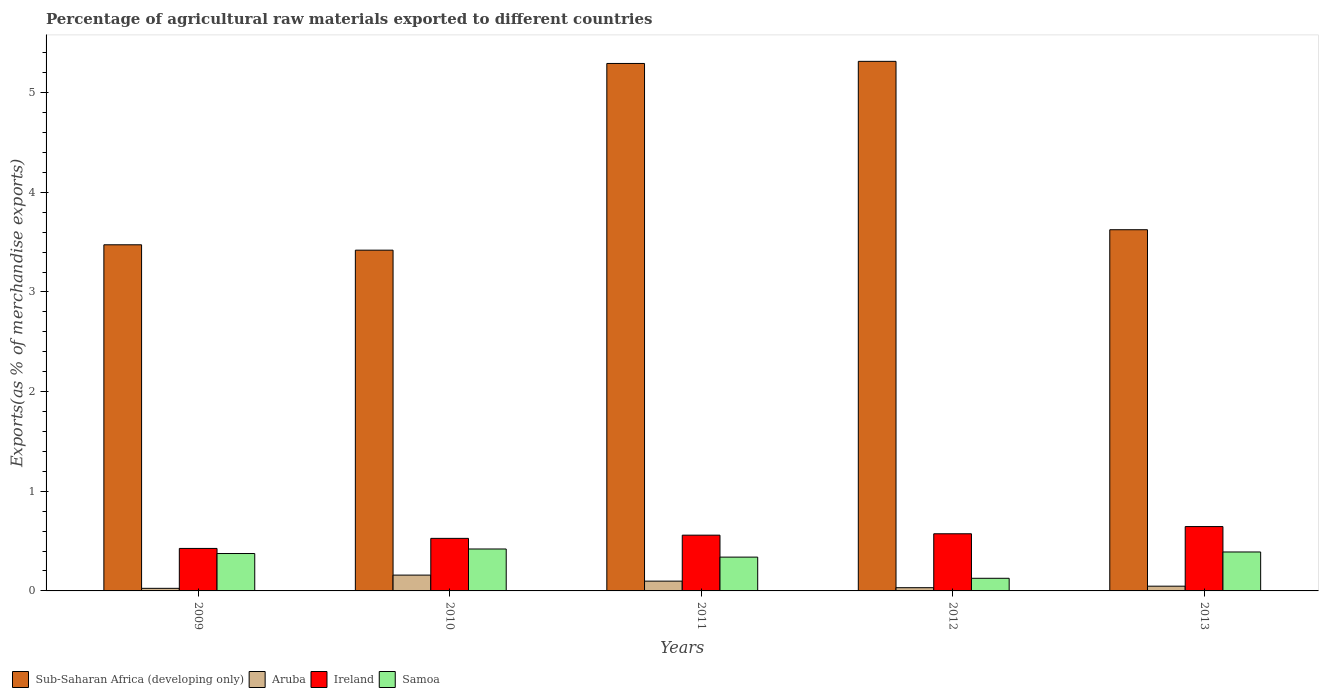How many groups of bars are there?
Offer a terse response. 5. How many bars are there on the 4th tick from the right?
Offer a very short reply. 4. What is the label of the 3rd group of bars from the left?
Ensure brevity in your answer.  2011. In how many cases, is the number of bars for a given year not equal to the number of legend labels?
Provide a short and direct response. 0. What is the percentage of exports to different countries in Sub-Saharan Africa (developing only) in 2012?
Provide a short and direct response. 5.31. Across all years, what is the maximum percentage of exports to different countries in Aruba?
Make the answer very short. 0.16. Across all years, what is the minimum percentage of exports to different countries in Sub-Saharan Africa (developing only)?
Offer a terse response. 3.42. What is the total percentage of exports to different countries in Aruba in the graph?
Your answer should be very brief. 0.36. What is the difference between the percentage of exports to different countries in Samoa in 2011 and that in 2013?
Your response must be concise. -0.05. What is the difference between the percentage of exports to different countries in Samoa in 2009 and the percentage of exports to different countries in Sub-Saharan Africa (developing only) in 2013?
Ensure brevity in your answer.  -3.25. What is the average percentage of exports to different countries in Sub-Saharan Africa (developing only) per year?
Give a very brief answer. 4.22. In the year 2011, what is the difference between the percentage of exports to different countries in Samoa and percentage of exports to different countries in Aruba?
Provide a succinct answer. 0.24. What is the ratio of the percentage of exports to different countries in Sub-Saharan Africa (developing only) in 2009 to that in 2012?
Provide a succinct answer. 0.65. Is the difference between the percentage of exports to different countries in Samoa in 2010 and 2011 greater than the difference between the percentage of exports to different countries in Aruba in 2010 and 2011?
Your answer should be very brief. Yes. What is the difference between the highest and the second highest percentage of exports to different countries in Samoa?
Make the answer very short. 0.03. What is the difference between the highest and the lowest percentage of exports to different countries in Ireland?
Give a very brief answer. 0.22. Is it the case that in every year, the sum of the percentage of exports to different countries in Aruba and percentage of exports to different countries in Ireland is greater than the sum of percentage of exports to different countries in Sub-Saharan Africa (developing only) and percentage of exports to different countries in Samoa?
Offer a very short reply. Yes. What does the 3rd bar from the left in 2009 represents?
Your answer should be compact. Ireland. What does the 2nd bar from the right in 2009 represents?
Make the answer very short. Ireland. Are all the bars in the graph horizontal?
Your response must be concise. No. Where does the legend appear in the graph?
Your answer should be compact. Bottom left. How many legend labels are there?
Offer a very short reply. 4. How are the legend labels stacked?
Your answer should be compact. Horizontal. What is the title of the graph?
Your response must be concise. Percentage of agricultural raw materials exported to different countries. What is the label or title of the X-axis?
Your answer should be compact. Years. What is the label or title of the Y-axis?
Provide a succinct answer. Exports(as % of merchandise exports). What is the Exports(as % of merchandise exports) of Sub-Saharan Africa (developing only) in 2009?
Keep it short and to the point. 3.47. What is the Exports(as % of merchandise exports) of Aruba in 2009?
Offer a very short reply. 0.03. What is the Exports(as % of merchandise exports) in Ireland in 2009?
Keep it short and to the point. 0.43. What is the Exports(as % of merchandise exports) of Samoa in 2009?
Provide a short and direct response. 0.38. What is the Exports(as % of merchandise exports) of Sub-Saharan Africa (developing only) in 2010?
Give a very brief answer. 3.42. What is the Exports(as % of merchandise exports) of Aruba in 2010?
Ensure brevity in your answer.  0.16. What is the Exports(as % of merchandise exports) in Ireland in 2010?
Offer a terse response. 0.53. What is the Exports(as % of merchandise exports) of Samoa in 2010?
Offer a terse response. 0.42. What is the Exports(as % of merchandise exports) in Sub-Saharan Africa (developing only) in 2011?
Give a very brief answer. 5.29. What is the Exports(as % of merchandise exports) of Aruba in 2011?
Provide a succinct answer. 0.1. What is the Exports(as % of merchandise exports) in Ireland in 2011?
Offer a very short reply. 0.56. What is the Exports(as % of merchandise exports) of Samoa in 2011?
Give a very brief answer. 0.34. What is the Exports(as % of merchandise exports) in Sub-Saharan Africa (developing only) in 2012?
Your answer should be compact. 5.31. What is the Exports(as % of merchandise exports) of Aruba in 2012?
Make the answer very short. 0.03. What is the Exports(as % of merchandise exports) of Ireland in 2012?
Your response must be concise. 0.57. What is the Exports(as % of merchandise exports) of Samoa in 2012?
Your answer should be very brief. 0.13. What is the Exports(as % of merchandise exports) of Sub-Saharan Africa (developing only) in 2013?
Your answer should be very brief. 3.62. What is the Exports(as % of merchandise exports) of Aruba in 2013?
Offer a very short reply. 0.05. What is the Exports(as % of merchandise exports) in Ireland in 2013?
Offer a very short reply. 0.65. What is the Exports(as % of merchandise exports) of Samoa in 2013?
Keep it short and to the point. 0.39. Across all years, what is the maximum Exports(as % of merchandise exports) in Sub-Saharan Africa (developing only)?
Make the answer very short. 5.31. Across all years, what is the maximum Exports(as % of merchandise exports) in Aruba?
Make the answer very short. 0.16. Across all years, what is the maximum Exports(as % of merchandise exports) of Ireland?
Offer a terse response. 0.65. Across all years, what is the maximum Exports(as % of merchandise exports) of Samoa?
Provide a short and direct response. 0.42. Across all years, what is the minimum Exports(as % of merchandise exports) in Sub-Saharan Africa (developing only)?
Give a very brief answer. 3.42. Across all years, what is the minimum Exports(as % of merchandise exports) of Aruba?
Provide a succinct answer. 0.03. Across all years, what is the minimum Exports(as % of merchandise exports) of Ireland?
Keep it short and to the point. 0.43. Across all years, what is the minimum Exports(as % of merchandise exports) of Samoa?
Offer a terse response. 0.13. What is the total Exports(as % of merchandise exports) of Sub-Saharan Africa (developing only) in the graph?
Give a very brief answer. 21.12. What is the total Exports(as % of merchandise exports) in Aruba in the graph?
Your response must be concise. 0.36. What is the total Exports(as % of merchandise exports) in Ireland in the graph?
Offer a very short reply. 2.73. What is the total Exports(as % of merchandise exports) of Samoa in the graph?
Give a very brief answer. 1.65. What is the difference between the Exports(as % of merchandise exports) in Sub-Saharan Africa (developing only) in 2009 and that in 2010?
Your answer should be compact. 0.05. What is the difference between the Exports(as % of merchandise exports) in Aruba in 2009 and that in 2010?
Your answer should be very brief. -0.13. What is the difference between the Exports(as % of merchandise exports) in Ireland in 2009 and that in 2010?
Ensure brevity in your answer.  -0.1. What is the difference between the Exports(as % of merchandise exports) in Samoa in 2009 and that in 2010?
Your response must be concise. -0.05. What is the difference between the Exports(as % of merchandise exports) in Sub-Saharan Africa (developing only) in 2009 and that in 2011?
Your response must be concise. -1.82. What is the difference between the Exports(as % of merchandise exports) of Aruba in 2009 and that in 2011?
Your answer should be compact. -0.07. What is the difference between the Exports(as % of merchandise exports) of Ireland in 2009 and that in 2011?
Ensure brevity in your answer.  -0.13. What is the difference between the Exports(as % of merchandise exports) of Samoa in 2009 and that in 2011?
Give a very brief answer. 0.04. What is the difference between the Exports(as % of merchandise exports) of Sub-Saharan Africa (developing only) in 2009 and that in 2012?
Provide a short and direct response. -1.84. What is the difference between the Exports(as % of merchandise exports) of Aruba in 2009 and that in 2012?
Offer a very short reply. -0.01. What is the difference between the Exports(as % of merchandise exports) in Ireland in 2009 and that in 2012?
Your response must be concise. -0.15. What is the difference between the Exports(as % of merchandise exports) in Samoa in 2009 and that in 2012?
Keep it short and to the point. 0.25. What is the difference between the Exports(as % of merchandise exports) in Sub-Saharan Africa (developing only) in 2009 and that in 2013?
Your response must be concise. -0.15. What is the difference between the Exports(as % of merchandise exports) in Aruba in 2009 and that in 2013?
Provide a short and direct response. -0.02. What is the difference between the Exports(as % of merchandise exports) in Ireland in 2009 and that in 2013?
Your answer should be compact. -0.22. What is the difference between the Exports(as % of merchandise exports) of Samoa in 2009 and that in 2013?
Give a very brief answer. -0.02. What is the difference between the Exports(as % of merchandise exports) in Sub-Saharan Africa (developing only) in 2010 and that in 2011?
Offer a terse response. -1.87. What is the difference between the Exports(as % of merchandise exports) in Aruba in 2010 and that in 2011?
Give a very brief answer. 0.06. What is the difference between the Exports(as % of merchandise exports) of Ireland in 2010 and that in 2011?
Ensure brevity in your answer.  -0.03. What is the difference between the Exports(as % of merchandise exports) of Samoa in 2010 and that in 2011?
Give a very brief answer. 0.08. What is the difference between the Exports(as % of merchandise exports) of Sub-Saharan Africa (developing only) in 2010 and that in 2012?
Your response must be concise. -1.89. What is the difference between the Exports(as % of merchandise exports) of Aruba in 2010 and that in 2012?
Offer a terse response. 0.13. What is the difference between the Exports(as % of merchandise exports) in Ireland in 2010 and that in 2012?
Your response must be concise. -0.05. What is the difference between the Exports(as % of merchandise exports) in Samoa in 2010 and that in 2012?
Provide a succinct answer. 0.29. What is the difference between the Exports(as % of merchandise exports) of Sub-Saharan Africa (developing only) in 2010 and that in 2013?
Provide a short and direct response. -0.2. What is the difference between the Exports(as % of merchandise exports) in Aruba in 2010 and that in 2013?
Provide a succinct answer. 0.11. What is the difference between the Exports(as % of merchandise exports) in Ireland in 2010 and that in 2013?
Offer a terse response. -0.12. What is the difference between the Exports(as % of merchandise exports) of Samoa in 2010 and that in 2013?
Make the answer very short. 0.03. What is the difference between the Exports(as % of merchandise exports) in Sub-Saharan Africa (developing only) in 2011 and that in 2012?
Keep it short and to the point. -0.02. What is the difference between the Exports(as % of merchandise exports) of Aruba in 2011 and that in 2012?
Ensure brevity in your answer.  0.07. What is the difference between the Exports(as % of merchandise exports) of Ireland in 2011 and that in 2012?
Offer a terse response. -0.01. What is the difference between the Exports(as % of merchandise exports) in Samoa in 2011 and that in 2012?
Ensure brevity in your answer.  0.21. What is the difference between the Exports(as % of merchandise exports) of Sub-Saharan Africa (developing only) in 2011 and that in 2013?
Offer a terse response. 1.67. What is the difference between the Exports(as % of merchandise exports) in Aruba in 2011 and that in 2013?
Your answer should be very brief. 0.05. What is the difference between the Exports(as % of merchandise exports) of Ireland in 2011 and that in 2013?
Provide a succinct answer. -0.09. What is the difference between the Exports(as % of merchandise exports) in Samoa in 2011 and that in 2013?
Provide a short and direct response. -0.05. What is the difference between the Exports(as % of merchandise exports) in Sub-Saharan Africa (developing only) in 2012 and that in 2013?
Offer a very short reply. 1.69. What is the difference between the Exports(as % of merchandise exports) in Aruba in 2012 and that in 2013?
Your response must be concise. -0.02. What is the difference between the Exports(as % of merchandise exports) of Ireland in 2012 and that in 2013?
Offer a terse response. -0.07. What is the difference between the Exports(as % of merchandise exports) in Samoa in 2012 and that in 2013?
Your response must be concise. -0.26. What is the difference between the Exports(as % of merchandise exports) in Sub-Saharan Africa (developing only) in 2009 and the Exports(as % of merchandise exports) in Aruba in 2010?
Offer a terse response. 3.31. What is the difference between the Exports(as % of merchandise exports) in Sub-Saharan Africa (developing only) in 2009 and the Exports(as % of merchandise exports) in Ireland in 2010?
Provide a succinct answer. 2.95. What is the difference between the Exports(as % of merchandise exports) of Sub-Saharan Africa (developing only) in 2009 and the Exports(as % of merchandise exports) of Samoa in 2010?
Keep it short and to the point. 3.05. What is the difference between the Exports(as % of merchandise exports) of Aruba in 2009 and the Exports(as % of merchandise exports) of Ireland in 2010?
Ensure brevity in your answer.  -0.5. What is the difference between the Exports(as % of merchandise exports) of Aruba in 2009 and the Exports(as % of merchandise exports) of Samoa in 2010?
Provide a short and direct response. -0.39. What is the difference between the Exports(as % of merchandise exports) of Ireland in 2009 and the Exports(as % of merchandise exports) of Samoa in 2010?
Your answer should be compact. 0.01. What is the difference between the Exports(as % of merchandise exports) of Sub-Saharan Africa (developing only) in 2009 and the Exports(as % of merchandise exports) of Aruba in 2011?
Provide a succinct answer. 3.38. What is the difference between the Exports(as % of merchandise exports) of Sub-Saharan Africa (developing only) in 2009 and the Exports(as % of merchandise exports) of Ireland in 2011?
Make the answer very short. 2.91. What is the difference between the Exports(as % of merchandise exports) of Sub-Saharan Africa (developing only) in 2009 and the Exports(as % of merchandise exports) of Samoa in 2011?
Offer a terse response. 3.13. What is the difference between the Exports(as % of merchandise exports) in Aruba in 2009 and the Exports(as % of merchandise exports) in Ireland in 2011?
Ensure brevity in your answer.  -0.53. What is the difference between the Exports(as % of merchandise exports) in Aruba in 2009 and the Exports(as % of merchandise exports) in Samoa in 2011?
Keep it short and to the point. -0.31. What is the difference between the Exports(as % of merchandise exports) in Ireland in 2009 and the Exports(as % of merchandise exports) in Samoa in 2011?
Give a very brief answer. 0.09. What is the difference between the Exports(as % of merchandise exports) in Sub-Saharan Africa (developing only) in 2009 and the Exports(as % of merchandise exports) in Aruba in 2012?
Provide a succinct answer. 3.44. What is the difference between the Exports(as % of merchandise exports) in Sub-Saharan Africa (developing only) in 2009 and the Exports(as % of merchandise exports) in Ireland in 2012?
Offer a very short reply. 2.9. What is the difference between the Exports(as % of merchandise exports) in Sub-Saharan Africa (developing only) in 2009 and the Exports(as % of merchandise exports) in Samoa in 2012?
Offer a terse response. 3.35. What is the difference between the Exports(as % of merchandise exports) in Aruba in 2009 and the Exports(as % of merchandise exports) in Ireland in 2012?
Make the answer very short. -0.55. What is the difference between the Exports(as % of merchandise exports) of Aruba in 2009 and the Exports(as % of merchandise exports) of Samoa in 2012?
Your response must be concise. -0.1. What is the difference between the Exports(as % of merchandise exports) in Ireland in 2009 and the Exports(as % of merchandise exports) in Samoa in 2012?
Make the answer very short. 0.3. What is the difference between the Exports(as % of merchandise exports) of Sub-Saharan Africa (developing only) in 2009 and the Exports(as % of merchandise exports) of Aruba in 2013?
Offer a very short reply. 3.43. What is the difference between the Exports(as % of merchandise exports) in Sub-Saharan Africa (developing only) in 2009 and the Exports(as % of merchandise exports) in Ireland in 2013?
Give a very brief answer. 2.83. What is the difference between the Exports(as % of merchandise exports) in Sub-Saharan Africa (developing only) in 2009 and the Exports(as % of merchandise exports) in Samoa in 2013?
Your response must be concise. 3.08. What is the difference between the Exports(as % of merchandise exports) of Aruba in 2009 and the Exports(as % of merchandise exports) of Ireland in 2013?
Make the answer very short. -0.62. What is the difference between the Exports(as % of merchandise exports) of Aruba in 2009 and the Exports(as % of merchandise exports) of Samoa in 2013?
Provide a short and direct response. -0.36. What is the difference between the Exports(as % of merchandise exports) of Ireland in 2009 and the Exports(as % of merchandise exports) of Samoa in 2013?
Your answer should be compact. 0.04. What is the difference between the Exports(as % of merchandise exports) of Sub-Saharan Africa (developing only) in 2010 and the Exports(as % of merchandise exports) of Aruba in 2011?
Make the answer very short. 3.32. What is the difference between the Exports(as % of merchandise exports) of Sub-Saharan Africa (developing only) in 2010 and the Exports(as % of merchandise exports) of Ireland in 2011?
Your answer should be compact. 2.86. What is the difference between the Exports(as % of merchandise exports) in Sub-Saharan Africa (developing only) in 2010 and the Exports(as % of merchandise exports) in Samoa in 2011?
Provide a short and direct response. 3.08. What is the difference between the Exports(as % of merchandise exports) of Aruba in 2010 and the Exports(as % of merchandise exports) of Ireland in 2011?
Provide a short and direct response. -0.4. What is the difference between the Exports(as % of merchandise exports) of Aruba in 2010 and the Exports(as % of merchandise exports) of Samoa in 2011?
Offer a very short reply. -0.18. What is the difference between the Exports(as % of merchandise exports) in Ireland in 2010 and the Exports(as % of merchandise exports) in Samoa in 2011?
Make the answer very short. 0.19. What is the difference between the Exports(as % of merchandise exports) of Sub-Saharan Africa (developing only) in 2010 and the Exports(as % of merchandise exports) of Aruba in 2012?
Give a very brief answer. 3.39. What is the difference between the Exports(as % of merchandise exports) of Sub-Saharan Africa (developing only) in 2010 and the Exports(as % of merchandise exports) of Ireland in 2012?
Make the answer very short. 2.85. What is the difference between the Exports(as % of merchandise exports) of Sub-Saharan Africa (developing only) in 2010 and the Exports(as % of merchandise exports) of Samoa in 2012?
Offer a terse response. 3.29. What is the difference between the Exports(as % of merchandise exports) of Aruba in 2010 and the Exports(as % of merchandise exports) of Ireland in 2012?
Your answer should be compact. -0.41. What is the difference between the Exports(as % of merchandise exports) of Aruba in 2010 and the Exports(as % of merchandise exports) of Samoa in 2012?
Give a very brief answer. 0.03. What is the difference between the Exports(as % of merchandise exports) in Ireland in 2010 and the Exports(as % of merchandise exports) in Samoa in 2012?
Make the answer very short. 0.4. What is the difference between the Exports(as % of merchandise exports) in Sub-Saharan Africa (developing only) in 2010 and the Exports(as % of merchandise exports) in Aruba in 2013?
Give a very brief answer. 3.37. What is the difference between the Exports(as % of merchandise exports) of Sub-Saharan Africa (developing only) in 2010 and the Exports(as % of merchandise exports) of Ireland in 2013?
Your answer should be very brief. 2.77. What is the difference between the Exports(as % of merchandise exports) of Sub-Saharan Africa (developing only) in 2010 and the Exports(as % of merchandise exports) of Samoa in 2013?
Provide a succinct answer. 3.03. What is the difference between the Exports(as % of merchandise exports) of Aruba in 2010 and the Exports(as % of merchandise exports) of Ireland in 2013?
Make the answer very short. -0.49. What is the difference between the Exports(as % of merchandise exports) in Aruba in 2010 and the Exports(as % of merchandise exports) in Samoa in 2013?
Your answer should be very brief. -0.23. What is the difference between the Exports(as % of merchandise exports) in Ireland in 2010 and the Exports(as % of merchandise exports) in Samoa in 2013?
Offer a terse response. 0.14. What is the difference between the Exports(as % of merchandise exports) in Sub-Saharan Africa (developing only) in 2011 and the Exports(as % of merchandise exports) in Aruba in 2012?
Provide a short and direct response. 5.26. What is the difference between the Exports(as % of merchandise exports) of Sub-Saharan Africa (developing only) in 2011 and the Exports(as % of merchandise exports) of Ireland in 2012?
Provide a short and direct response. 4.72. What is the difference between the Exports(as % of merchandise exports) in Sub-Saharan Africa (developing only) in 2011 and the Exports(as % of merchandise exports) in Samoa in 2012?
Your answer should be compact. 5.17. What is the difference between the Exports(as % of merchandise exports) in Aruba in 2011 and the Exports(as % of merchandise exports) in Ireland in 2012?
Keep it short and to the point. -0.48. What is the difference between the Exports(as % of merchandise exports) in Aruba in 2011 and the Exports(as % of merchandise exports) in Samoa in 2012?
Provide a short and direct response. -0.03. What is the difference between the Exports(as % of merchandise exports) of Ireland in 2011 and the Exports(as % of merchandise exports) of Samoa in 2012?
Give a very brief answer. 0.43. What is the difference between the Exports(as % of merchandise exports) of Sub-Saharan Africa (developing only) in 2011 and the Exports(as % of merchandise exports) of Aruba in 2013?
Your answer should be compact. 5.25. What is the difference between the Exports(as % of merchandise exports) in Sub-Saharan Africa (developing only) in 2011 and the Exports(as % of merchandise exports) in Ireland in 2013?
Ensure brevity in your answer.  4.65. What is the difference between the Exports(as % of merchandise exports) of Sub-Saharan Africa (developing only) in 2011 and the Exports(as % of merchandise exports) of Samoa in 2013?
Keep it short and to the point. 4.9. What is the difference between the Exports(as % of merchandise exports) in Aruba in 2011 and the Exports(as % of merchandise exports) in Ireland in 2013?
Provide a short and direct response. -0.55. What is the difference between the Exports(as % of merchandise exports) of Aruba in 2011 and the Exports(as % of merchandise exports) of Samoa in 2013?
Provide a short and direct response. -0.29. What is the difference between the Exports(as % of merchandise exports) in Ireland in 2011 and the Exports(as % of merchandise exports) in Samoa in 2013?
Offer a very short reply. 0.17. What is the difference between the Exports(as % of merchandise exports) of Sub-Saharan Africa (developing only) in 2012 and the Exports(as % of merchandise exports) of Aruba in 2013?
Ensure brevity in your answer.  5.27. What is the difference between the Exports(as % of merchandise exports) of Sub-Saharan Africa (developing only) in 2012 and the Exports(as % of merchandise exports) of Ireland in 2013?
Keep it short and to the point. 4.67. What is the difference between the Exports(as % of merchandise exports) of Sub-Saharan Africa (developing only) in 2012 and the Exports(as % of merchandise exports) of Samoa in 2013?
Offer a terse response. 4.92. What is the difference between the Exports(as % of merchandise exports) in Aruba in 2012 and the Exports(as % of merchandise exports) in Ireland in 2013?
Offer a very short reply. -0.61. What is the difference between the Exports(as % of merchandise exports) in Aruba in 2012 and the Exports(as % of merchandise exports) in Samoa in 2013?
Make the answer very short. -0.36. What is the difference between the Exports(as % of merchandise exports) in Ireland in 2012 and the Exports(as % of merchandise exports) in Samoa in 2013?
Provide a succinct answer. 0.18. What is the average Exports(as % of merchandise exports) in Sub-Saharan Africa (developing only) per year?
Your answer should be very brief. 4.22. What is the average Exports(as % of merchandise exports) in Aruba per year?
Offer a very short reply. 0.07. What is the average Exports(as % of merchandise exports) of Ireland per year?
Offer a very short reply. 0.55. What is the average Exports(as % of merchandise exports) of Samoa per year?
Your answer should be compact. 0.33. In the year 2009, what is the difference between the Exports(as % of merchandise exports) of Sub-Saharan Africa (developing only) and Exports(as % of merchandise exports) of Aruba?
Your answer should be very brief. 3.45. In the year 2009, what is the difference between the Exports(as % of merchandise exports) of Sub-Saharan Africa (developing only) and Exports(as % of merchandise exports) of Ireland?
Your response must be concise. 3.05. In the year 2009, what is the difference between the Exports(as % of merchandise exports) in Sub-Saharan Africa (developing only) and Exports(as % of merchandise exports) in Samoa?
Your answer should be very brief. 3.1. In the year 2009, what is the difference between the Exports(as % of merchandise exports) of Aruba and Exports(as % of merchandise exports) of Ireland?
Provide a succinct answer. -0.4. In the year 2009, what is the difference between the Exports(as % of merchandise exports) in Aruba and Exports(as % of merchandise exports) in Samoa?
Keep it short and to the point. -0.35. In the year 2009, what is the difference between the Exports(as % of merchandise exports) of Ireland and Exports(as % of merchandise exports) of Samoa?
Your answer should be very brief. 0.05. In the year 2010, what is the difference between the Exports(as % of merchandise exports) of Sub-Saharan Africa (developing only) and Exports(as % of merchandise exports) of Aruba?
Your response must be concise. 3.26. In the year 2010, what is the difference between the Exports(as % of merchandise exports) of Sub-Saharan Africa (developing only) and Exports(as % of merchandise exports) of Ireland?
Provide a succinct answer. 2.89. In the year 2010, what is the difference between the Exports(as % of merchandise exports) of Sub-Saharan Africa (developing only) and Exports(as % of merchandise exports) of Samoa?
Your answer should be very brief. 3. In the year 2010, what is the difference between the Exports(as % of merchandise exports) in Aruba and Exports(as % of merchandise exports) in Ireland?
Offer a very short reply. -0.37. In the year 2010, what is the difference between the Exports(as % of merchandise exports) of Aruba and Exports(as % of merchandise exports) of Samoa?
Your answer should be compact. -0.26. In the year 2010, what is the difference between the Exports(as % of merchandise exports) of Ireland and Exports(as % of merchandise exports) of Samoa?
Your answer should be very brief. 0.11. In the year 2011, what is the difference between the Exports(as % of merchandise exports) in Sub-Saharan Africa (developing only) and Exports(as % of merchandise exports) in Aruba?
Make the answer very short. 5.19. In the year 2011, what is the difference between the Exports(as % of merchandise exports) of Sub-Saharan Africa (developing only) and Exports(as % of merchandise exports) of Ireland?
Your answer should be very brief. 4.73. In the year 2011, what is the difference between the Exports(as % of merchandise exports) of Sub-Saharan Africa (developing only) and Exports(as % of merchandise exports) of Samoa?
Your response must be concise. 4.95. In the year 2011, what is the difference between the Exports(as % of merchandise exports) in Aruba and Exports(as % of merchandise exports) in Ireland?
Your response must be concise. -0.46. In the year 2011, what is the difference between the Exports(as % of merchandise exports) in Aruba and Exports(as % of merchandise exports) in Samoa?
Make the answer very short. -0.24. In the year 2011, what is the difference between the Exports(as % of merchandise exports) in Ireland and Exports(as % of merchandise exports) in Samoa?
Make the answer very short. 0.22. In the year 2012, what is the difference between the Exports(as % of merchandise exports) of Sub-Saharan Africa (developing only) and Exports(as % of merchandise exports) of Aruba?
Give a very brief answer. 5.28. In the year 2012, what is the difference between the Exports(as % of merchandise exports) of Sub-Saharan Africa (developing only) and Exports(as % of merchandise exports) of Ireland?
Provide a short and direct response. 4.74. In the year 2012, what is the difference between the Exports(as % of merchandise exports) of Sub-Saharan Africa (developing only) and Exports(as % of merchandise exports) of Samoa?
Ensure brevity in your answer.  5.19. In the year 2012, what is the difference between the Exports(as % of merchandise exports) in Aruba and Exports(as % of merchandise exports) in Ireland?
Provide a short and direct response. -0.54. In the year 2012, what is the difference between the Exports(as % of merchandise exports) of Aruba and Exports(as % of merchandise exports) of Samoa?
Provide a short and direct response. -0.09. In the year 2012, what is the difference between the Exports(as % of merchandise exports) in Ireland and Exports(as % of merchandise exports) in Samoa?
Give a very brief answer. 0.45. In the year 2013, what is the difference between the Exports(as % of merchandise exports) in Sub-Saharan Africa (developing only) and Exports(as % of merchandise exports) in Aruba?
Offer a terse response. 3.58. In the year 2013, what is the difference between the Exports(as % of merchandise exports) of Sub-Saharan Africa (developing only) and Exports(as % of merchandise exports) of Ireland?
Your answer should be very brief. 2.98. In the year 2013, what is the difference between the Exports(as % of merchandise exports) in Sub-Saharan Africa (developing only) and Exports(as % of merchandise exports) in Samoa?
Offer a very short reply. 3.23. In the year 2013, what is the difference between the Exports(as % of merchandise exports) in Aruba and Exports(as % of merchandise exports) in Ireland?
Give a very brief answer. -0.6. In the year 2013, what is the difference between the Exports(as % of merchandise exports) of Aruba and Exports(as % of merchandise exports) of Samoa?
Your answer should be very brief. -0.34. In the year 2013, what is the difference between the Exports(as % of merchandise exports) of Ireland and Exports(as % of merchandise exports) of Samoa?
Your answer should be compact. 0.25. What is the ratio of the Exports(as % of merchandise exports) of Sub-Saharan Africa (developing only) in 2009 to that in 2010?
Give a very brief answer. 1.02. What is the ratio of the Exports(as % of merchandise exports) in Aruba in 2009 to that in 2010?
Provide a short and direct response. 0.16. What is the ratio of the Exports(as % of merchandise exports) of Ireland in 2009 to that in 2010?
Offer a very short reply. 0.81. What is the ratio of the Exports(as % of merchandise exports) in Samoa in 2009 to that in 2010?
Keep it short and to the point. 0.89. What is the ratio of the Exports(as % of merchandise exports) of Sub-Saharan Africa (developing only) in 2009 to that in 2011?
Your answer should be compact. 0.66. What is the ratio of the Exports(as % of merchandise exports) in Aruba in 2009 to that in 2011?
Your answer should be very brief. 0.26. What is the ratio of the Exports(as % of merchandise exports) in Ireland in 2009 to that in 2011?
Your answer should be very brief. 0.76. What is the ratio of the Exports(as % of merchandise exports) in Samoa in 2009 to that in 2011?
Offer a very short reply. 1.11. What is the ratio of the Exports(as % of merchandise exports) in Sub-Saharan Africa (developing only) in 2009 to that in 2012?
Provide a succinct answer. 0.65. What is the ratio of the Exports(as % of merchandise exports) of Aruba in 2009 to that in 2012?
Provide a succinct answer. 0.8. What is the ratio of the Exports(as % of merchandise exports) of Ireland in 2009 to that in 2012?
Keep it short and to the point. 0.74. What is the ratio of the Exports(as % of merchandise exports) of Samoa in 2009 to that in 2012?
Offer a terse response. 2.96. What is the ratio of the Exports(as % of merchandise exports) in Sub-Saharan Africa (developing only) in 2009 to that in 2013?
Keep it short and to the point. 0.96. What is the ratio of the Exports(as % of merchandise exports) in Aruba in 2009 to that in 2013?
Provide a short and direct response. 0.55. What is the ratio of the Exports(as % of merchandise exports) in Ireland in 2009 to that in 2013?
Give a very brief answer. 0.66. What is the ratio of the Exports(as % of merchandise exports) of Samoa in 2009 to that in 2013?
Provide a short and direct response. 0.96. What is the ratio of the Exports(as % of merchandise exports) in Sub-Saharan Africa (developing only) in 2010 to that in 2011?
Ensure brevity in your answer.  0.65. What is the ratio of the Exports(as % of merchandise exports) in Aruba in 2010 to that in 2011?
Ensure brevity in your answer.  1.62. What is the ratio of the Exports(as % of merchandise exports) in Ireland in 2010 to that in 2011?
Offer a very short reply. 0.94. What is the ratio of the Exports(as % of merchandise exports) in Samoa in 2010 to that in 2011?
Provide a short and direct response. 1.24. What is the ratio of the Exports(as % of merchandise exports) in Sub-Saharan Africa (developing only) in 2010 to that in 2012?
Offer a very short reply. 0.64. What is the ratio of the Exports(as % of merchandise exports) in Aruba in 2010 to that in 2012?
Keep it short and to the point. 4.9. What is the ratio of the Exports(as % of merchandise exports) of Ireland in 2010 to that in 2012?
Offer a very short reply. 0.92. What is the ratio of the Exports(as % of merchandise exports) in Samoa in 2010 to that in 2012?
Ensure brevity in your answer.  3.32. What is the ratio of the Exports(as % of merchandise exports) in Sub-Saharan Africa (developing only) in 2010 to that in 2013?
Your answer should be very brief. 0.94. What is the ratio of the Exports(as % of merchandise exports) of Aruba in 2010 to that in 2013?
Ensure brevity in your answer.  3.34. What is the ratio of the Exports(as % of merchandise exports) in Ireland in 2010 to that in 2013?
Keep it short and to the point. 0.82. What is the ratio of the Exports(as % of merchandise exports) in Samoa in 2010 to that in 2013?
Your response must be concise. 1.08. What is the ratio of the Exports(as % of merchandise exports) in Sub-Saharan Africa (developing only) in 2011 to that in 2012?
Ensure brevity in your answer.  1. What is the ratio of the Exports(as % of merchandise exports) of Aruba in 2011 to that in 2012?
Provide a succinct answer. 3.04. What is the ratio of the Exports(as % of merchandise exports) in Ireland in 2011 to that in 2012?
Provide a succinct answer. 0.98. What is the ratio of the Exports(as % of merchandise exports) of Samoa in 2011 to that in 2012?
Your response must be concise. 2.68. What is the ratio of the Exports(as % of merchandise exports) of Sub-Saharan Africa (developing only) in 2011 to that in 2013?
Your answer should be very brief. 1.46. What is the ratio of the Exports(as % of merchandise exports) of Aruba in 2011 to that in 2013?
Make the answer very short. 2.07. What is the ratio of the Exports(as % of merchandise exports) in Ireland in 2011 to that in 2013?
Ensure brevity in your answer.  0.87. What is the ratio of the Exports(as % of merchandise exports) in Samoa in 2011 to that in 2013?
Offer a very short reply. 0.87. What is the ratio of the Exports(as % of merchandise exports) in Sub-Saharan Africa (developing only) in 2012 to that in 2013?
Your answer should be compact. 1.47. What is the ratio of the Exports(as % of merchandise exports) of Aruba in 2012 to that in 2013?
Give a very brief answer. 0.68. What is the ratio of the Exports(as % of merchandise exports) in Ireland in 2012 to that in 2013?
Offer a very short reply. 0.89. What is the ratio of the Exports(as % of merchandise exports) of Samoa in 2012 to that in 2013?
Keep it short and to the point. 0.32. What is the difference between the highest and the second highest Exports(as % of merchandise exports) in Sub-Saharan Africa (developing only)?
Make the answer very short. 0.02. What is the difference between the highest and the second highest Exports(as % of merchandise exports) in Aruba?
Your response must be concise. 0.06. What is the difference between the highest and the second highest Exports(as % of merchandise exports) in Ireland?
Provide a succinct answer. 0.07. What is the difference between the highest and the second highest Exports(as % of merchandise exports) of Samoa?
Give a very brief answer. 0.03. What is the difference between the highest and the lowest Exports(as % of merchandise exports) of Sub-Saharan Africa (developing only)?
Give a very brief answer. 1.89. What is the difference between the highest and the lowest Exports(as % of merchandise exports) of Aruba?
Give a very brief answer. 0.13. What is the difference between the highest and the lowest Exports(as % of merchandise exports) of Ireland?
Offer a very short reply. 0.22. What is the difference between the highest and the lowest Exports(as % of merchandise exports) of Samoa?
Your answer should be very brief. 0.29. 